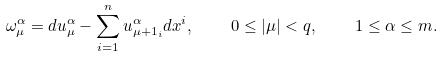<formula> <loc_0><loc_0><loc_500><loc_500>\omega ^ { \alpha } _ { \mu } = d u ^ { \alpha } _ { \mu } - \sum _ { i = 1 } ^ { n } u ^ { \alpha } _ { \mu + 1 _ { i } } d x ^ { i } , \quad 0 \leq | \mu | < q , \quad 1 \leq \alpha \leq m .</formula> 